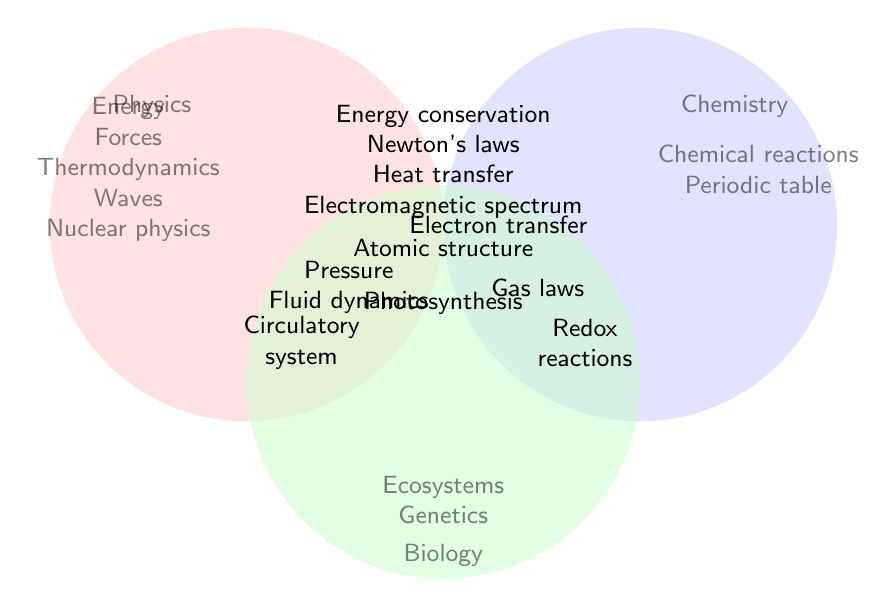What concepts do Physics and Chemistry share? The overlapping concepts between Physics and Chemistry are placed at the intersection of the two circles in the Venn Diagram. Thus, the shared concepts are "Pressure," "Atomic structure," "Electron transfer," and "Gas laws."
Answer: Pressure, Atomic structure, Electron transfer, Gas laws Which subject shares the concept of "Energy conservation" with Physics? The concept of "Energy conservation" is shown in the intersection between the circles representing Physics and the other subjects. However, only "Energy conservation" is shown in the middle indicating that it is a shared concept among all three: Physics, Biology, and Chemistry.
Answer: Biology and Chemistry List concepts that are unique to Chemistry. Unique concepts are those found only in the Chemistry circle, without overlap with other circles. For Chemistry, these are "Chemical reactions" and "Periodic table."
Answer: Chemical reactions, Periodic table Does Biology have any shared concepts with Chemistry? To see if Biology shares concepts with Chemistry, we check the intersections where only Biology and Chemistry overlap. "Photosynthesis" and "Electron transfer" are shared concepts between Biology and Chemistry as indicated.
Answer: Photosynthesis, Electron transfer What subjects overlap with Fluid dynamics? The "Fluid dynamics" concept appears in an intersection area involving Physics and is located near "Pressure" and "Circulatory system." Given its placement, Biology (circulatory system) and Chemistry (pressure) along with Physics are the subjects involved.
Answer: Biology, Chemistry Which concept is shared by all three subjects: Physics, Biology, and Chemistry? The center of the Venn Diagram will contain concepts common to all three disciplines. Only "Energy conservation" is present in the central region, indicating it is shared by all three subjects.
Answer: Energy conservation Identify the subject that does not appear in any overlap? To find this, we must look for all areas outside the intersections of the Venn Diagram. Checking Physics, Biology, and Chemistry, Observing each exclusive area, "Genetics" in Biology is the only area exclusive to one subject.
Answer: Genetics How many unique concepts are listed in the Physics circle? Unique concepts are distinguished in regions not overlapping with other circles. Observing the Physics circle, the unique concepts listed are "Energy," "Forces," "Thermodynamics," "Waves," and "Nuclear physics," totaling five unique concepts.
Answer: 5 Which concept related to Biology is involved with the circulatory system? Within the Biology circle, or its intersections, "Circulatory system" is directly noted. The corresponding concept in the Physics intersects that relates to "Fluid dynamics," hence connecting both.
Answer: Fluid dynamics What concept connects Redox reactions and Photosynthesis? Referring to overlapping areas in Biology and Chemistry, "Electron transfer" falls at their intersection near "Redox reactions" in Chemistry and "Photosynthesis" in Biology, denoting their linkage.
Answer: Electron transfer 